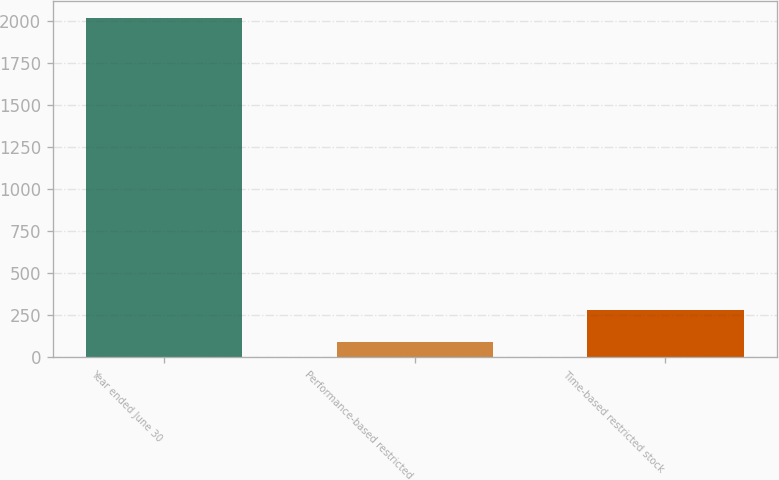Convert chart to OTSL. <chart><loc_0><loc_0><loc_500><loc_500><bar_chart><fcel>Year ended June 30<fcel>Performance-based restricted<fcel>Time-based restricted stock<nl><fcel>2017<fcel>90.63<fcel>283.27<nl></chart> 